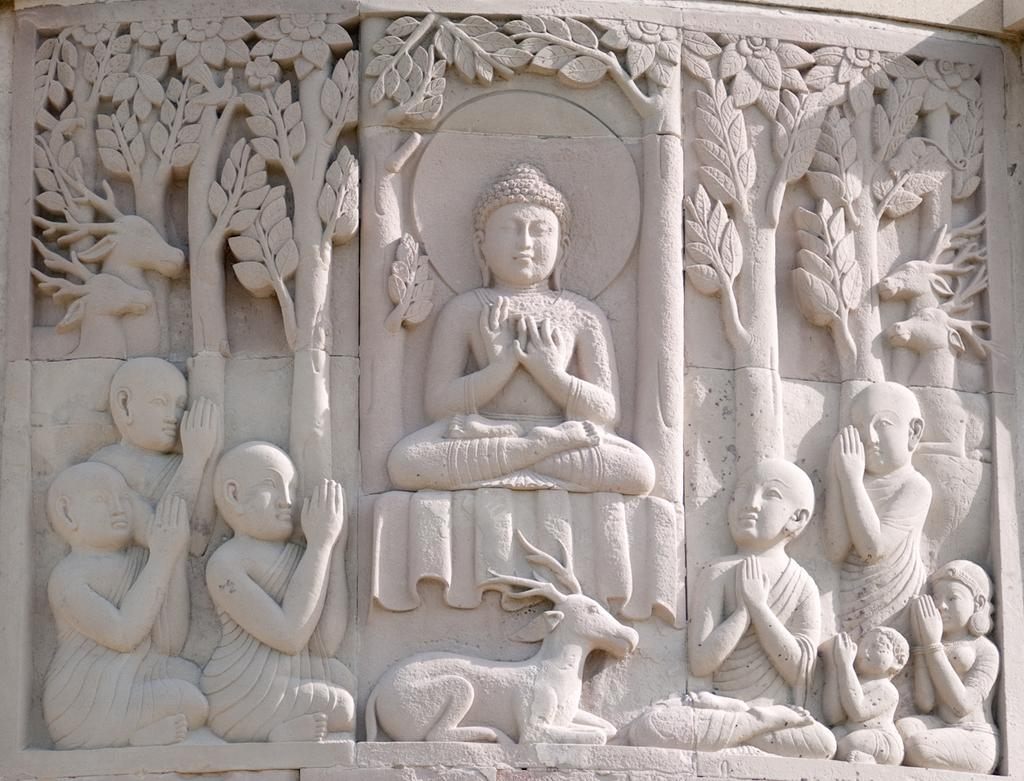What is the main subject of the image? There is a sculpture of a Buddha in the image. How many people are in the image? There are many people in the image. What type of animal is present in the image? There is an animal in the image. What can be seen in the background of the image? There are many trees and a wall in the image. What type of band is playing in the image? There is no band present in the image. What is the relation between the animal and the sculpture in the image? The provided facts do not mention any relation between the animal and the sculpture in the image. 